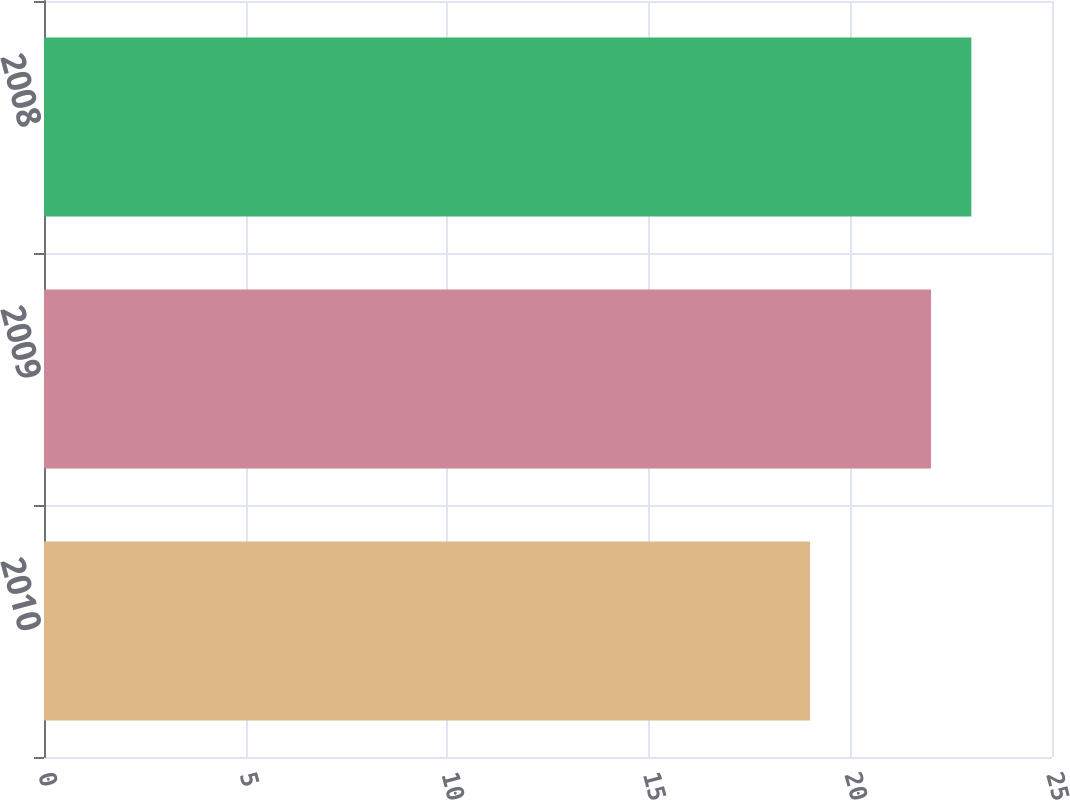Convert chart. <chart><loc_0><loc_0><loc_500><loc_500><bar_chart><fcel>2010<fcel>2009<fcel>2008<nl><fcel>19<fcel>22<fcel>23<nl></chart> 